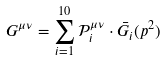<formula> <loc_0><loc_0><loc_500><loc_500>G ^ { \mu \nu } = \sum _ { i = 1 } ^ { 1 0 } \mathcal { P } ^ { \mu \nu } _ { i } \cdot \bar { G } _ { i } ( p ^ { 2 } )</formula> 